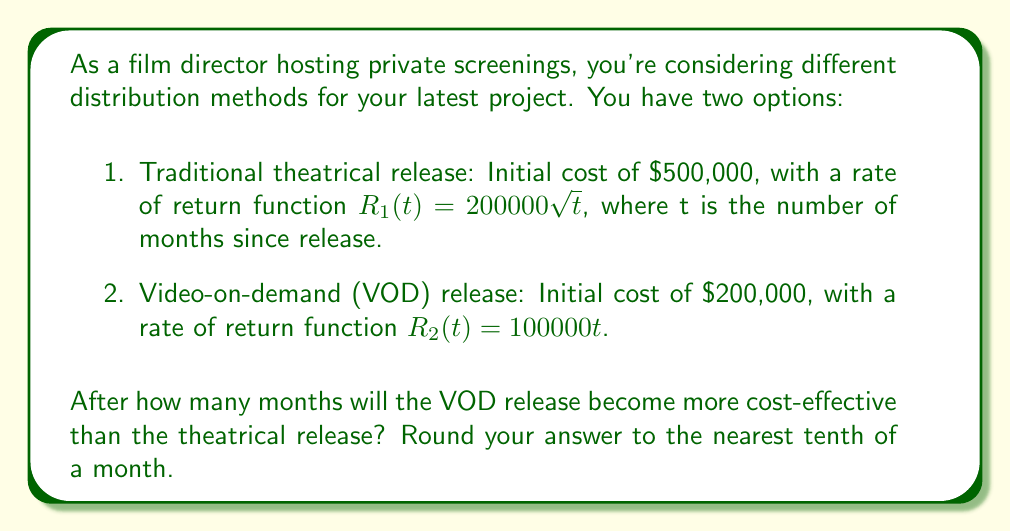Give your solution to this math problem. To solve this problem, we need to compare the net profits of both distribution methods over time. The net profit is the revenue minus the initial cost.

1. For the theatrical release:
   Net profit = $R_1(t) - 500000 = 200000\sqrt{t} - 500000$

2. For the VOD release:
   Net profit = $R_2(t) - 200000 = 100000t - 200000$

To find when the VOD release becomes more cost-effective, we need to set these net profits equal to each other and solve for t:

$$200000\sqrt{t} - 500000 = 100000t - 200000$$

Rearranging the equation:

$$200000\sqrt{t} = 100000t + 300000$$

Dividing both sides by 100000:

$$2\sqrt{t} = t + 3$$

Squaring both sides:

$$4t = t^2 + 6t + 9$$

Rearranging:

$$t^2 + 2t - 9 = 0$$

This is a quadratic equation. We can solve it using the quadratic formula:

$$t = \frac{-b \pm \sqrt{b^2 - 4ac}}{2a}$$

Where $a = 1$, $b = 2$, and $c = -9$

$$t = \frac{-2 \pm \sqrt{4 - 4(1)(-9)}}{2(1)} = \frac{-2 \pm \sqrt{40}}{2}$$

$$t = \frac{-2 \pm 6.32}{2}$$

The positive solution is:

$$t = \frac{-2 + 6.32}{2} = 2.16$$

Rounding to the nearest tenth, we get 2.2 months.
Answer: 2.2 months 